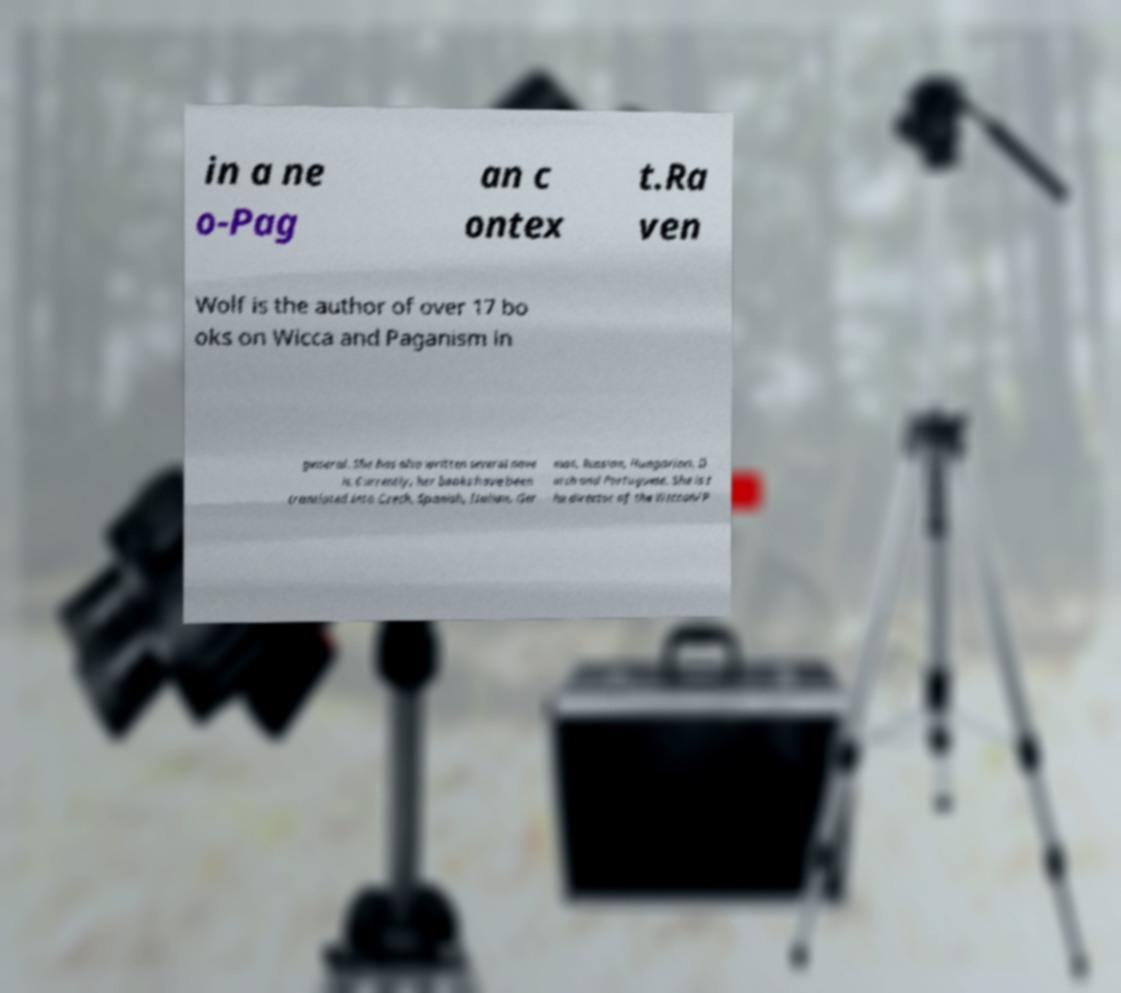Please read and relay the text visible in this image. What does it say? in a ne o-Pag an c ontex t.Ra ven Wolf is the author of over 17 bo oks on Wicca and Paganism in general. She has also written several nove ls. Currently, her books have been translated into Czech, Spanish, Italian, Ger man, Russian, Hungarian, D utch and Portuguese. She is t he director of the Wiccan/P 